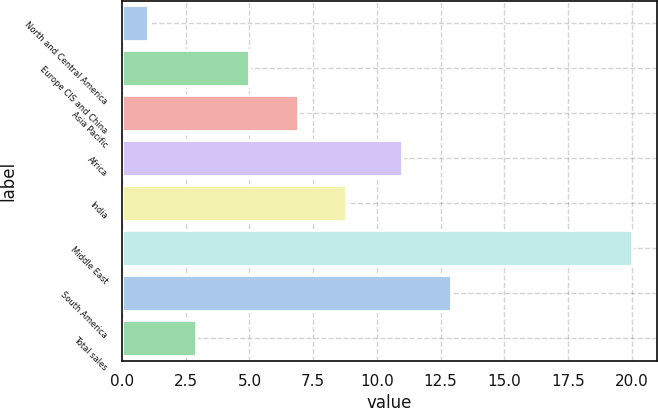Convert chart. <chart><loc_0><loc_0><loc_500><loc_500><bar_chart><fcel>North and Central America<fcel>Europe CIS and China<fcel>Asia Pacific<fcel>Africa<fcel>India<fcel>Middle East<fcel>South America<fcel>Total sales<nl><fcel>1<fcel>5<fcel>6.9<fcel>11<fcel>8.8<fcel>20<fcel>12.9<fcel>2.9<nl></chart> 